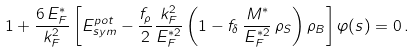Convert formula to latex. <formula><loc_0><loc_0><loc_500><loc_500>1 + \frac { 6 \, E ^ { * } _ { F } } { k ^ { 2 } _ { F } } \left [ E _ { s y m } ^ { p o t } - \frac { f _ { \rho } } { 2 } \frac { k ^ { 2 } _ { F } } { E ^ { * 2 } _ { F } } \left ( 1 - f _ { \delta } \, \frac { M ^ { * } } { E ^ { * 2 } _ { F } } \, \rho _ { S } \right ) \rho _ { B } \right ] \varphi ( s ) = 0 \, .</formula> 